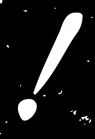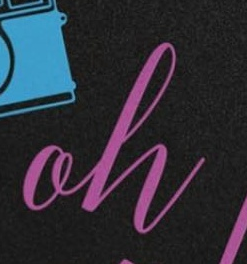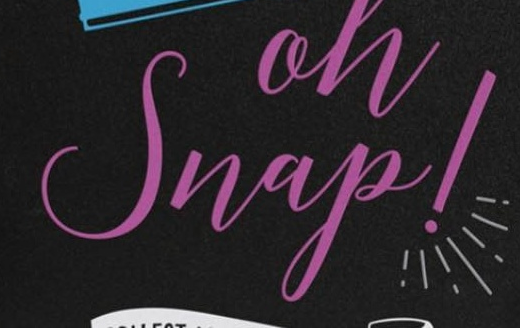Transcribe the words shown in these images in order, separated by a semicolon. !; oh; Snap! 